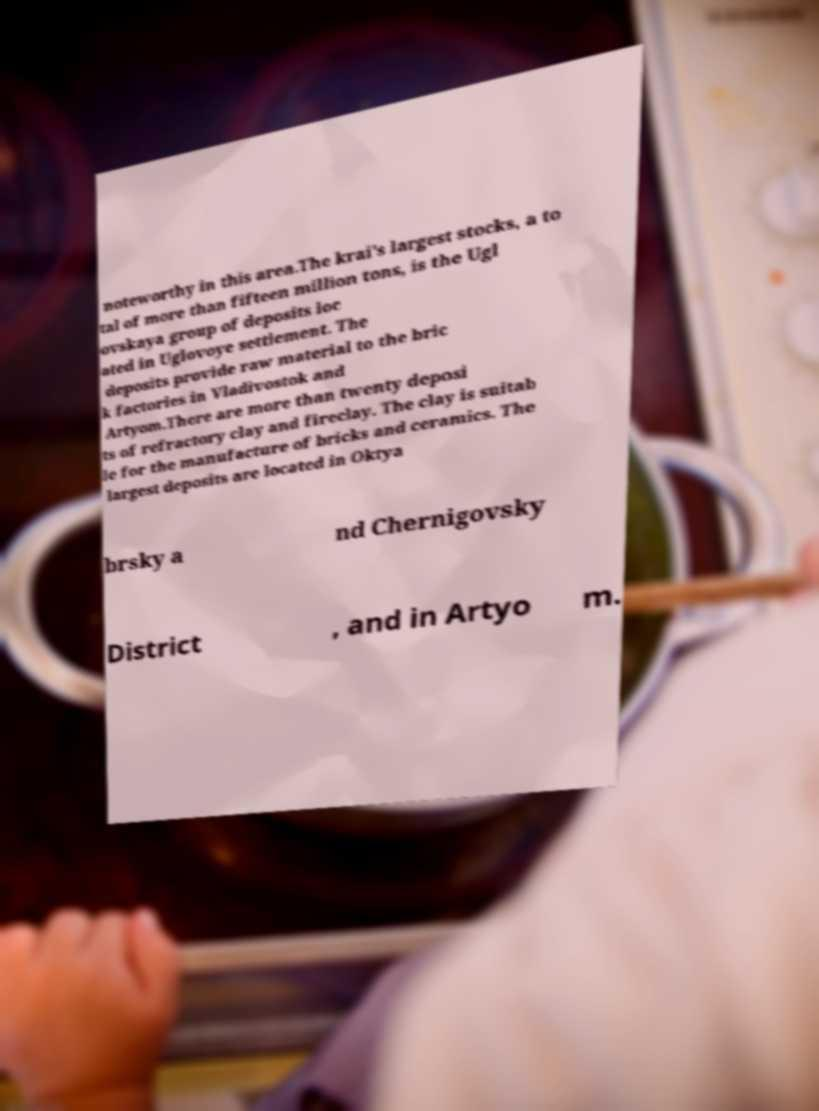Can you read and provide the text displayed in the image?This photo seems to have some interesting text. Can you extract and type it out for me? noteworthy in this area.The krai's largest stocks, a to tal of more than fifteen million tons, is the Ugl ovskaya group of deposits loc ated in Uglovoye settlement. The deposits provide raw material to the bric k factories in Vladivostok and Artyom.There are more than twenty deposi ts of refractory clay and fireclay. The clay is suitab le for the manufacture of bricks and ceramics. The largest deposits are located in Oktya brsky a nd Chernigovsky District , and in Artyo m. 